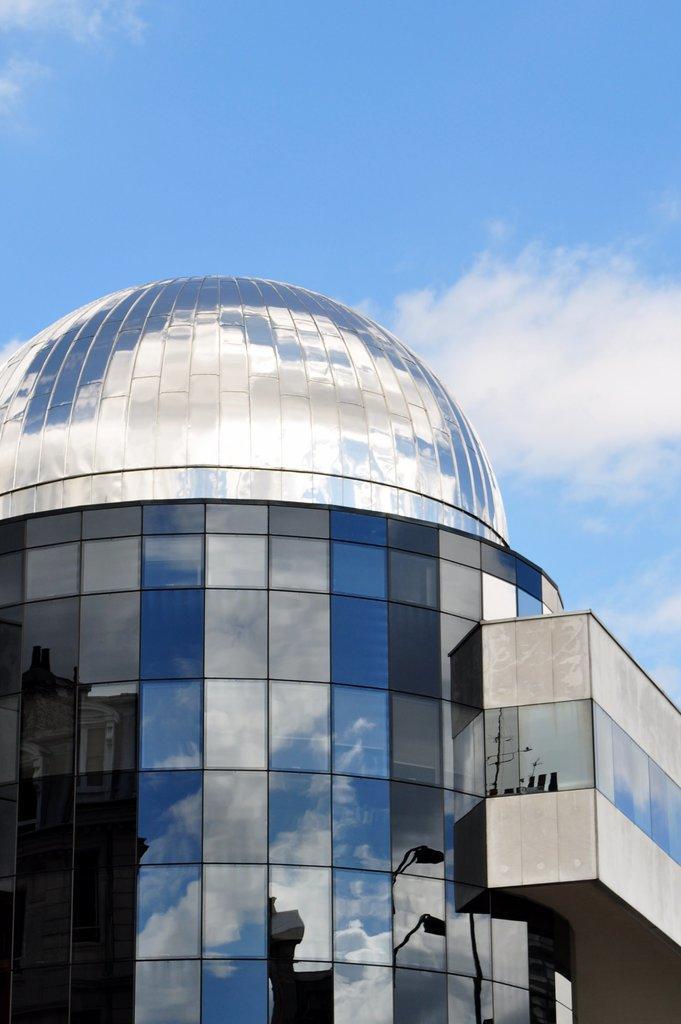Could you give a brief overview of what you see in this image? In this image, we can see a glass building. At the top, we can see a sky which is a bit cloudy. 